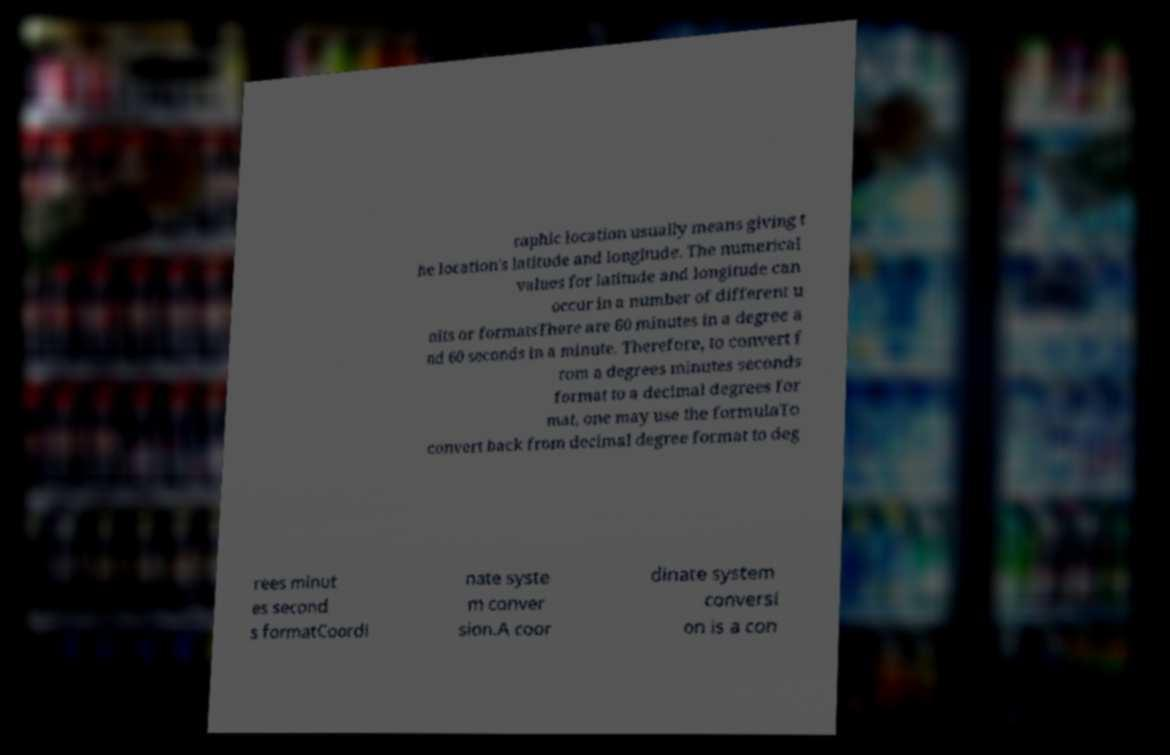There's text embedded in this image that I need extracted. Can you transcribe it verbatim? raphic location usually means giving t he location's latitude and longitude. The numerical values for latitude and longitude can occur in a number of different u nits or formatsThere are 60 minutes in a degree a nd 60 seconds in a minute. Therefore, to convert f rom a degrees minutes seconds format to a decimal degrees for mat, one may use the formulaTo convert back from decimal degree format to deg rees minut es second s formatCoordi nate syste m conver sion.A coor dinate system conversi on is a con 